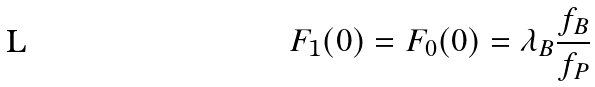<formula> <loc_0><loc_0><loc_500><loc_500>F _ { 1 } ( 0 ) = F _ { 0 } ( 0 ) = \lambda _ { B } \frac { f _ { B } } { f _ { P } }</formula> 